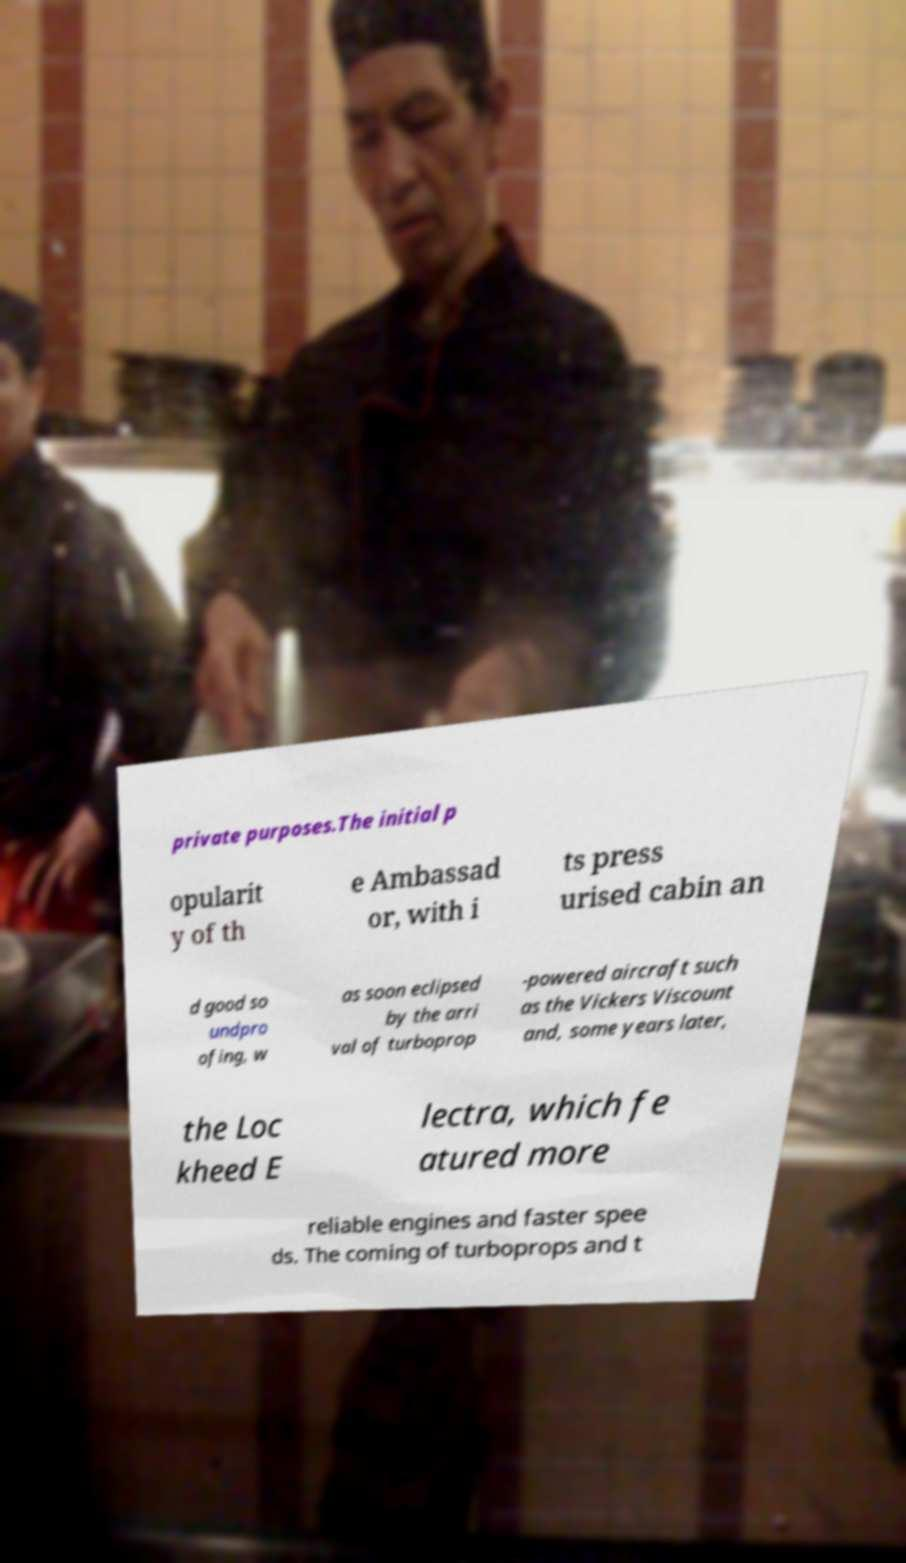Please identify and transcribe the text found in this image. private purposes.The initial p opularit y of th e Ambassad or, with i ts press urised cabin an d good so undpro ofing, w as soon eclipsed by the arri val of turboprop -powered aircraft such as the Vickers Viscount and, some years later, the Loc kheed E lectra, which fe atured more reliable engines and faster spee ds. The coming of turboprops and t 